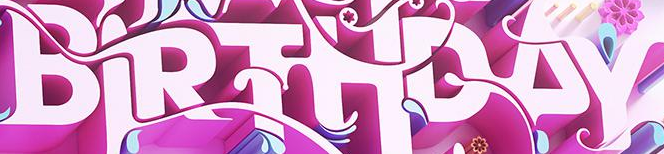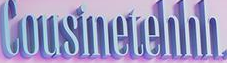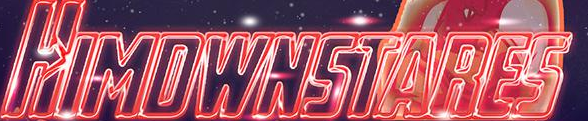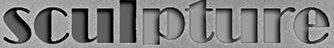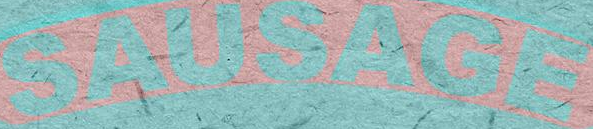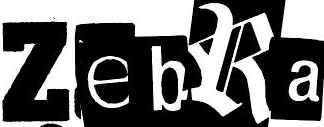What words can you see in these images in sequence, separated by a semicolon? BIRTHDAY; Cousinetehhh; HIMDWNSTARES; sculpture; SAUSAGE; ZebRa 